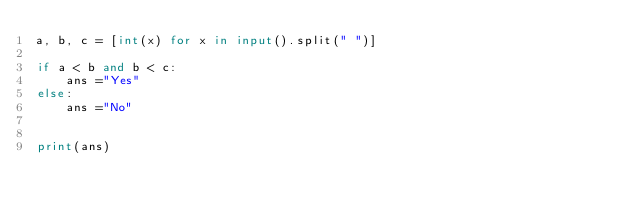Convert code to text. <code><loc_0><loc_0><loc_500><loc_500><_Python_>a, b, c = [int(x) for x in input().split(" ")]

if a < b and b < c:
    ans ="Yes"
else:
    ans ="No"


print(ans)</code> 